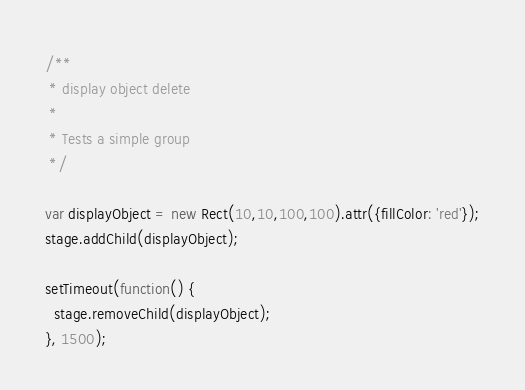<code> <loc_0><loc_0><loc_500><loc_500><_JavaScript_>/**
 * display object delete
 *
 * Tests a simple group
 */

var displayObject = new Rect(10,10,100,100).attr({fillColor: 'red'});
stage.addChild(displayObject);

setTimeout(function() {
  stage.removeChild(displayObject);
}, 1500);
</code> 